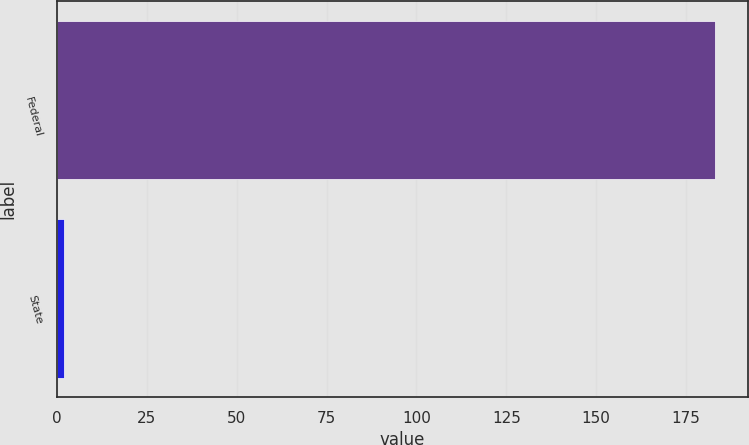Convert chart. <chart><loc_0><loc_0><loc_500><loc_500><bar_chart><fcel>Federal<fcel>State<nl><fcel>183<fcel>2<nl></chart> 